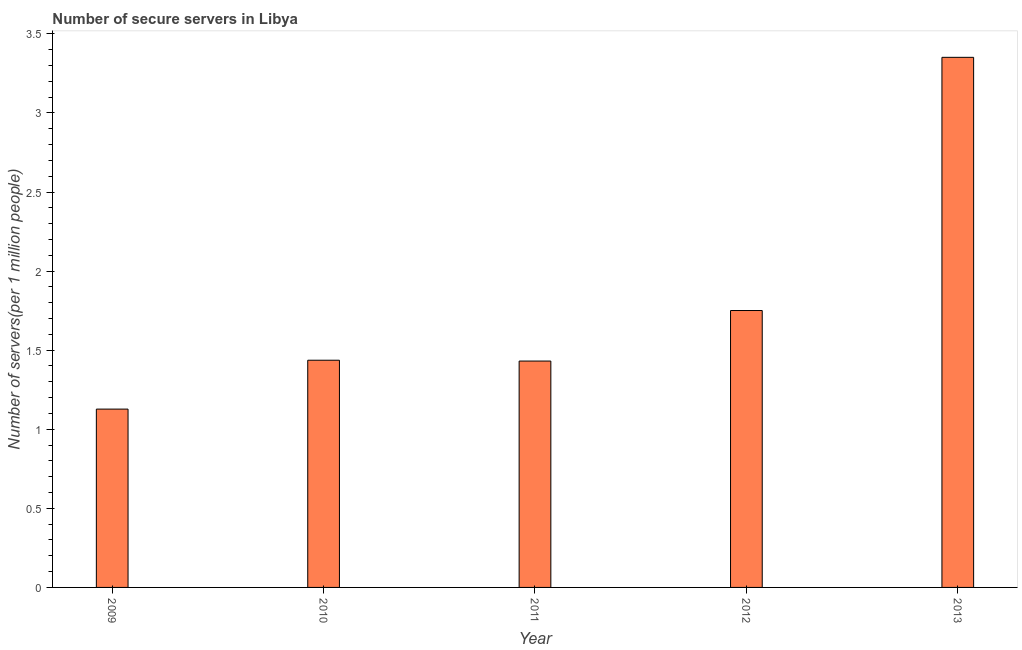Does the graph contain any zero values?
Provide a succinct answer. No. Does the graph contain grids?
Ensure brevity in your answer.  No. What is the title of the graph?
Provide a succinct answer. Number of secure servers in Libya. What is the label or title of the Y-axis?
Offer a terse response. Number of servers(per 1 million people). What is the number of secure internet servers in 2013?
Make the answer very short. 3.35. Across all years, what is the maximum number of secure internet servers?
Keep it short and to the point. 3.35. Across all years, what is the minimum number of secure internet servers?
Make the answer very short. 1.13. In which year was the number of secure internet servers maximum?
Your answer should be compact. 2013. In which year was the number of secure internet servers minimum?
Offer a very short reply. 2009. What is the sum of the number of secure internet servers?
Your response must be concise. 9.1. What is the difference between the number of secure internet servers in 2009 and 2011?
Provide a short and direct response. -0.3. What is the average number of secure internet servers per year?
Ensure brevity in your answer.  1.82. What is the median number of secure internet servers?
Offer a very short reply. 1.44. In how many years, is the number of secure internet servers greater than 2.9 ?
Ensure brevity in your answer.  1. What is the ratio of the number of secure internet servers in 2011 to that in 2013?
Make the answer very short. 0.43. Is the number of secure internet servers in 2010 less than that in 2013?
Give a very brief answer. Yes. What is the difference between the highest and the second highest number of secure internet servers?
Your response must be concise. 1.6. What is the difference between the highest and the lowest number of secure internet servers?
Your answer should be very brief. 2.22. What is the Number of servers(per 1 million people) in 2009?
Provide a succinct answer. 1.13. What is the Number of servers(per 1 million people) of 2010?
Provide a short and direct response. 1.44. What is the Number of servers(per 1 million people) in 2011?
Your answer should be compact. 1.43. What is the Number of servers(per 1 million people) in 2012?
Provide a short and direct response. 1.75. What is the Number of servers(per 1 million people) of 2013?
Provide a short and direct response. 3.35. What is the difference between the Number of servers(per 1 million people) in 2009 and 2010?
Your answer should be very brief. -0.31. What is the difference between the Number of servers(per 1 million people) in 2009 and 2011?
Your answer should be compact. -0.3. What is the difference between the Number of servers(per 1 million people) in 2009 and 2012?
Keep it short and to the point. -0.62. What is the difference between the Number of servers(per 1 million people) in 2009 and 2013?
Your response must be concise. -2.22. What is the difference between the Number of servers(per 1 million people) in 2010 and 2011?
Your answer should be compact. 0.01. What is the difference between the Number of servers(per 1 million people) in 2010 and 2012?
Your answer should be very brief. -0.31. What is the difference between the Number of servers(per 1 million people) in 2010 and 2013?
Your answer should be compact. -1.92. What is the difference between the Number of servers(per 1 million people) in 2011 and 2012?
Provide a short and direct response. -0.32. What is the difference between the Number of servers(per 1 million people) in 2011 and 2013?
Offer a terse response. -1.92. What is the difference between the Number of servers(per 1 million people) in 2012 and 2013?
Offer a very short reply. -1.6. What is the ratio of the Number of servers(per 1 million people) in 2009 to that in 2010?
Offer a very short reply. 0.79. What is the ratio of the Number of servers(per 1 million people) in 2009 to that in 2011?
Provide a short and direct response. 0.79. What is the ratio of the Number of servers(per 1 million people) in 2009 to that in 2012?
Give a very brief answer. 0.64. What is the ratio of the Number of servers(per 1 million people) in 2009 to that in 2013?
Provide a succinct answer. 0.34. What is the ratio of the Number of servers(per 1 million people) in 2010 to that in 2012?
Provide a short and direct response. 0.82. What is the ratio of the Number of servers(per 1 million people) in 2010 to that in 2013?
Keep it short and to the point. 0.43. What is the ratio of the Number of servers(per 1 million people) in 2011 to that in 2012?
Make the answer very short. 0.82. What is the ratio of the Number of servers(per 1 million people) in 2011 to that in 2013?
Give a very brief answer. 0.43. What is the ratio of the Number of servers(per 1 million people) in 2012 to that in 2013?
Provide a short and direct response. 0.52. 